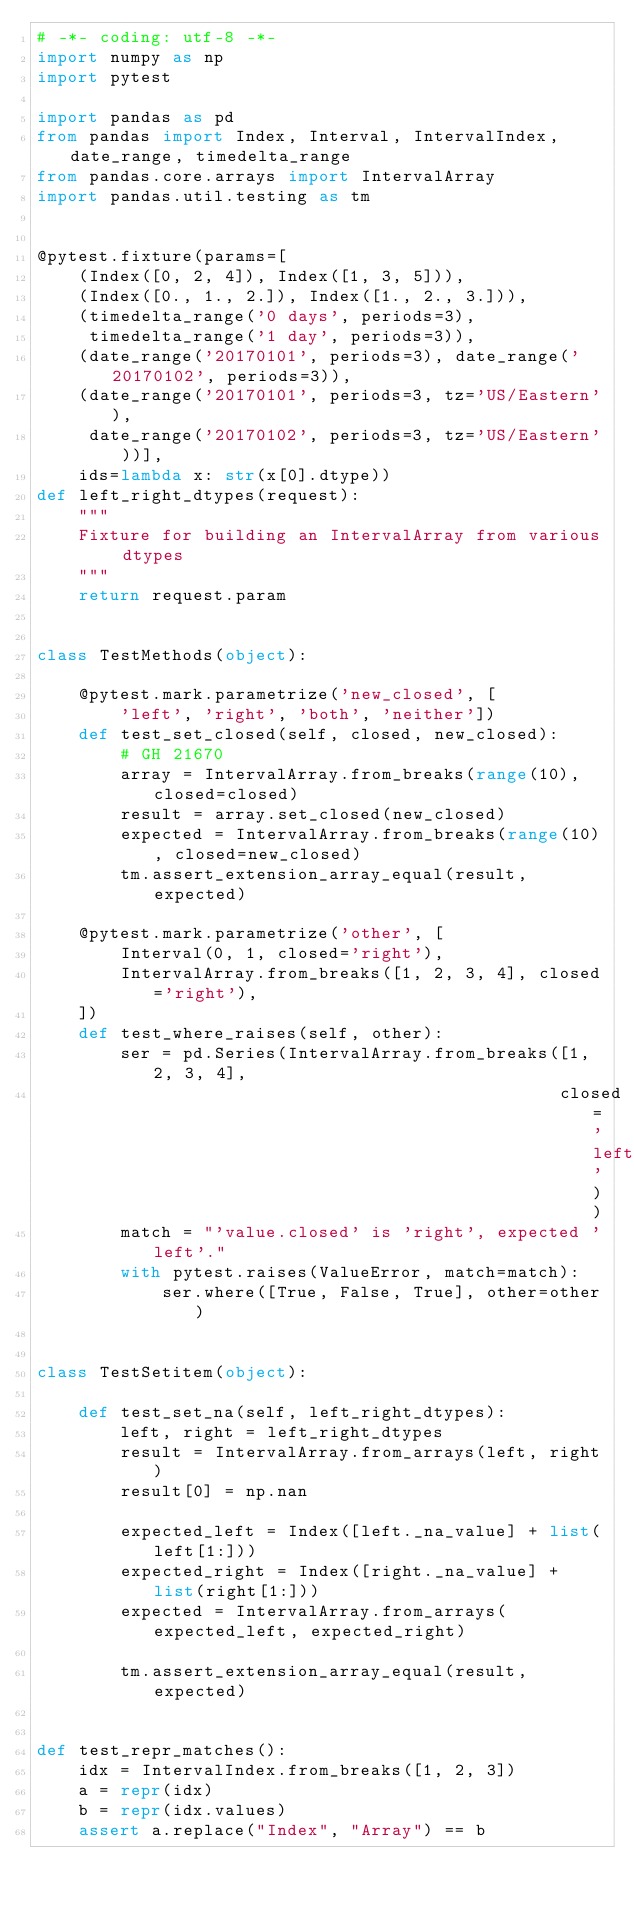Convert code to text. <code><loc_0><loc_0><loc_500><loc_500><_Python_># -*- coding: utf-8 -*-
import numpy as np
import pytest

import pandas as pd
from pandas import Index, Interval, IntervalIndex, date_range, timedelta_range
from pandas.core.arrays import IntervalArray
import pandas.util.testing as tm


@pytest.fixture(params=[
    (Index([0, 2, 4]), Index([1, 3, 5])),
    (Index([0., 1., 2.]), Index([1., 2., 3.])),
    (timedelta_range('0 days', periods=3),
     timedelta_range('1 day', periods=3)),
    (date_range('20170101', periods=3), date_range('20170102', periods=3)),
    (date_range('20170101', periods=3, tz='US/Eastern'),
     date_range('20170102', periods=3, tz='US/Eastern'))],
    ids=lambda x: str(x[0].dtype))
def left_right_dtypes(request):
    """
    Fixture for building an IntervalArray from various dtypes
    """
    return request.param


class TestMethods(object):

    @pytest.mark.parametrize('new_closed', [
        'left', 'right', 'both', 'neither'])
    def test_set_closed(self, closed, new_closed):
        # GH 21670
        array = IntervalArray.from_breaks(range(10), closed=closed)
        result = array.set_closed(new_closed)
        expected = IntervalArray.from_breaks(range(10), closed=new_closed)
        tm.assert_extension_array_equal(result, expected)

    @pytest.mark.parametrize('other', [
        Interval(0, 1, closed='right'),
        IntervalArray.from_breaks([1, 2, 3, 4], closed='right'),
    ])
    def test_where_raises(self, other):
        ser = pd.Series(IntervalArray.from_breaks([1, 2, 3, 4],
                                                  closed='left'))
        match = "'value.closed' is 'right', expected 'left'."
        with pytest.raises(ValueError, match=match):
            ser.where([True, False, True], other=other)


class TestSetitem(object):

    def test_set_na(self, left_right_dtypes):
        left, right = left_right_dtypes
        result = IntervalArray.from_arrays(left, right)
        result[0] = np.nan

        expected_left = Index([left._na_value] + list(left[1:]))
        expected_right = Index([right._na_value] + list(right[1:]))
        expected = IntervalArray.from_arrays(expected_left, expected_right)

        tm.assert_extension_array_equal(result, expected)


def test_repr_matches():
    idx = IntervalIndex.from_breaks([1, 2, 3])
    a = repr(idx)
    b = repr(idx.values)
    assert a.replace("Index", "Array") == b
</code> 